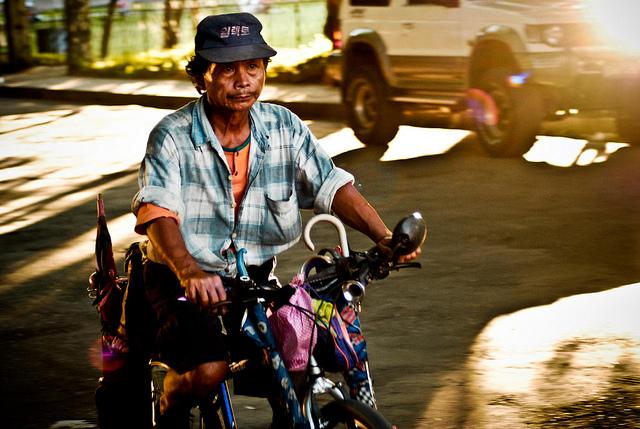What is the man riding?
Short answer required. Bicycle. Do you like the man's outfit?
Concise answer only. No. What does this man have on his left bicycle handle?
Short answer required. Umbrella. 